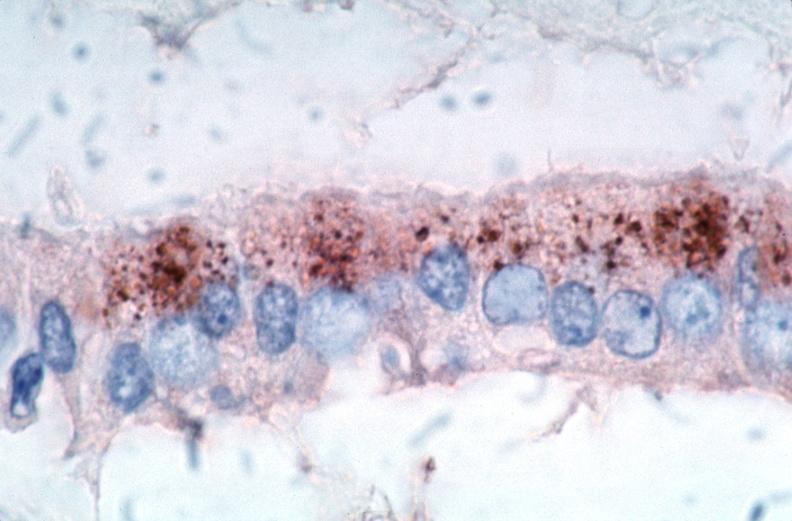does this image show vasculitis?
Answer the question using a single word or phrase. Yes 